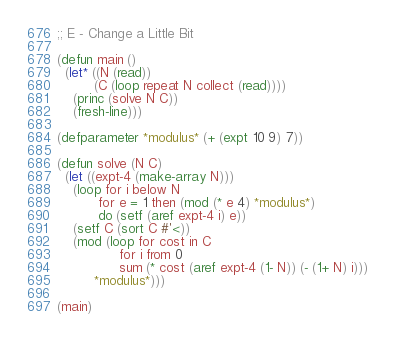Convert code to text. <code><loc_0><loc_0><loc_500><loc_500><_Lisp_>;; E - Change a Little Bit

(defun main ()
  (let* ((N (read))
         (C (loop repeat N collect (read))))
    (princ (solve N C))
    (fresh-line)))

(defparameter *modulus* (+ (expt 10 9) 7))

(defun solve (N C)
  (let ((expt-4 (make-array N)))
    (loop for i below N
          for e = 1 then (mod (* e 4) *modulus*)
          do (setf (aref expt-4 i) e))
    (setf C (sort C #'<))
    (mod (loop for cost in C
               for i from 0
               sum (* cost (aref expt-4 (1- N)) (- (1+ N) i)))
         *modulus*)))

(main)
</code> 